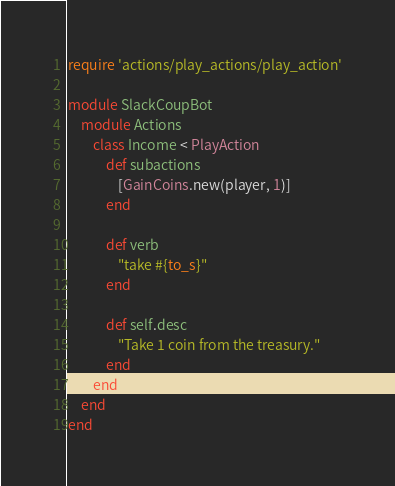<code> <loc_0><loc_0><loc_500><loc_500><_Ruby_>require 'actions/play_actions/play_action'

module SlackCoupBot
	module Actions
		class Income < PlayAction
			def subactions
				[GainCoins.new(player, 1)]
			end

			def verb
				"take #{to_s}"
			end

			def self.desc
				"Take 1 coin from the treasury."
			end
		end
	end
end</code> 